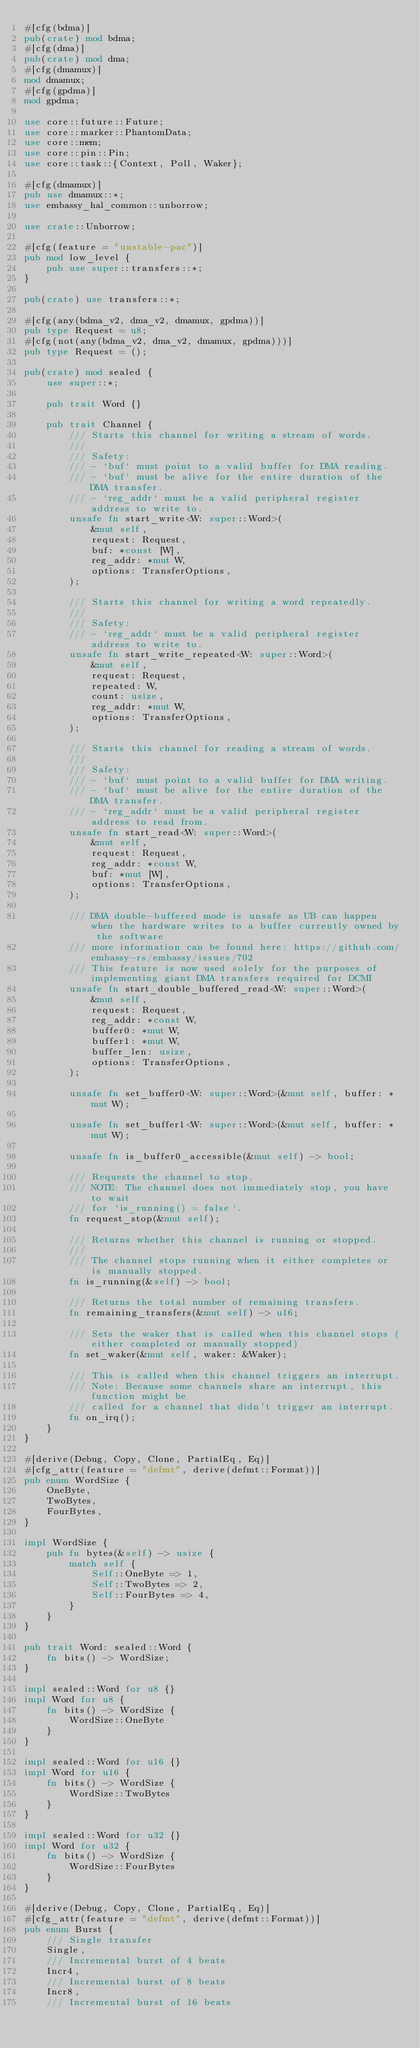Convert code to text. <code><loc_0><loc_0><loc_500><loc_500><_Rust_>#[cfg(bdma)]
pub(crate) mod bdma;
#[cfg(dma)]
pub(crate) mod dma;
#[cfg(dmamux)]
mod dmamux;
#[cfg(gpdma)]
mod gpdma;

use core::future::Future;
use core::marker::PhantomData;
use core::mem;
use core::pin::Pin;
use core::task::{Context, Poll, Waker};

#[cfg(dmamux)]
pub use dmamux::*;
use embassy_hal_common::unborrow;

use crate::Unborrow;

#[cfg(feature = "unstable-pac")]
pub mod low_level {
    pub use super::transfers::*;
}

pub(crate) use transfers::*;

#[cfg(any(bdma_v2, dma_v2, dmamux, gpdma))]
pub type Request = u8;
#[cfg(not(any(bdma_v2, dma_v2, dmamux, gpdma)))]
pub type Request = ();

pub(crate) mod sealed {
    use super::*;

    pub trait Word {}

    pub trait Channel {
        /// Starts this channel for writing a stream of words.
        ///
        /// Safety:
        /// - `buf` must point to a valid buffer for DMA reading.
        /// - `buf` must be alive for the entire duration of the DMA transfer.
        /// - `reg_addr` must be a valid peripheral register address to write to.
        unsafe fn start_write<W: super::Word>(
            &mut self,
            request: Request,
            buf: *const [W],
            reg_addr: *mut W,
            options: TransferOptions,
        );

        /// Starts this channel for writing a word repeatedly.
        ///
        /// Safety:
        /// - `reg_addr` must be a valid peripheral register address to write to.
        unsafe fn start_write_repeated<W: super::Word>(
            &mut self,
            request: Request,
            repeated: W,
            count: usize,
            reg_addr: *mut W,
            options: TransferOptions,
        );

        /// Starts this channel for reading a stream of words.
        ///
        /// Safety:
        /// - `buf` must point to a valid buffer for DMA writing.
        /// - `buf` must be alive for the entire duration of the DMA transfer.
        /// - `reg_addr` must be a valid peripheral register address to read from.
        unsafe fn start_read<W: super::Word>(
            &mut self,
            request: Request,
            reg_addr: *const W,
            buf: *mut [W],
            options: TransferOptions,
        );

        /// DMA double-buffered mode is unsafe as UB can happen when the hardware writes to a buffer currently owned by the software
        /// more information can be found here: https://github.com/embassy-rs/embassy/issues/702
        /// This feature is now used solely for the purposes of implementing giant DMA transfers required for DCMI
        unsafe fn start_double_buffered_read<W: super::Word>(
            &mut self,
            request: Request,
            reg_addr: *const W,
            buffer0: *mut W,
            buffer1: *mut W,
            buffer_len: usize,
            options: TransferOptions,
        );

        unsafe fn set_buffer0<W: super::Word>(&mut self, buffer: *mut W);

        unsafe fn set_buffer1<W: super::Word>(&mut self, buffer: *mut W);

        unsafe fn is_buffer0_accessible(&mut self) -> bool;

        /// Requests the channel to stop.
        /// NOTE: The channel does not immediately stop, you have to wait
        /// for `is_running() = false`.
        fn request_stop(&mut self);

        /// Returns whether this channel is running or stopped.
        ///
        /// The channel stops running when it either completes or is manually stopped.
        fn is_running(&self) -> bool;

        /// Returns the total number of remaining transfers.
        fn remaining_transfers(&mut self) -> u16;

        /// Sets the waker that is called when this channel stops (either completed or manually stopped)
        fn set_waker(&mut self, waker: &Waker);

        /// This is called when this channel triggers an interrupt.
        /// Note: Because some channels share an interrupt, this function might be
        /// called for a channel that didn't trigger an interrupt.
        fn on_irq();
    }
}

#[derive(Debug, Copy, Clone, PartialEq, Eq)]
#[cfg_attr(feature = "defmt", derive(defmt::Format))]
pub enum WordSize {
    OneByte,
    TwoBytes,
    FourBytes,
}

impl WordSize {
    pub fn bytes(&self) -> usize {
        match self {
            Self::OneByte => 1,
            Self::TwoBytes => 2,
            Self::FourBytes => 4,
        }
    }
}

pub trait Word: sealed::Word {
    fn bits() -> WordSize;
}

impl sealed::Word for u8 {}
impl Word for u8 {
    fn bits() -> WordSize {
        WordSize::OneByte
    }
}

impl sealed::Word for u16 {}
impl Word for u16 {
    fn bits() -> WordSize {
        WordSize::TwoBytes
    }
}

impl sealed::Word for u32 {}
impl Word for u32 {
    fn bits() -> WordSize {
        WordSize::FourBytes
    }
}

#[derive(Debug, Copy, Clone, PartialEq, Eq)]
#[cfg_attr(feature = "defmt", derive(defmt::Format))]
pub enum Burst {
    /// Single transfer
    Single,
    /// Incremental burst of 4 beats
    Incr4,
    /// Incremental burst of 8 beats
    Incr8,
    /// Incremental burst of 16 beats</code> 